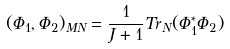Convert formula to latex. <formula><loc_0><loc_0><loc_500><loc_500>( \Phi _ { 1 } , \Phi _ { 2 } ) _ { M N } = \frac { 1 } { J + 1 } T r _ { N } ( \Phi _ { 1 } ^ { * } \Phi _ { 2 } )</formula> 